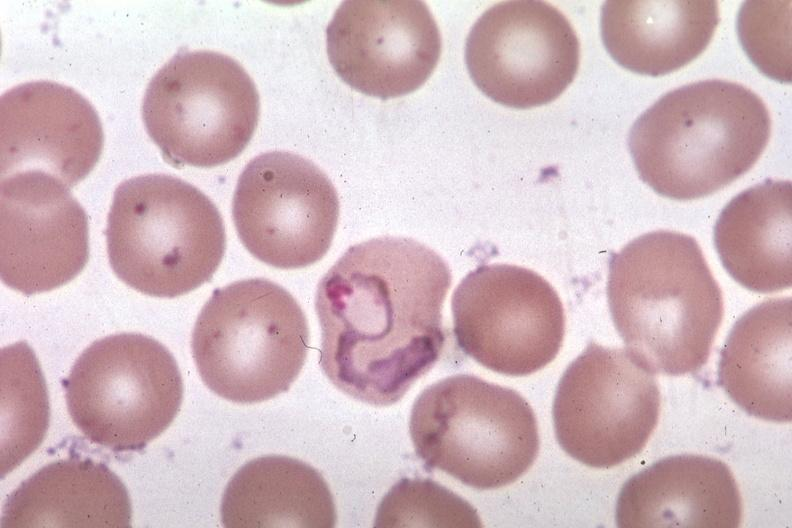s blood present?
Answer the question using a single word or phrase. Yes 